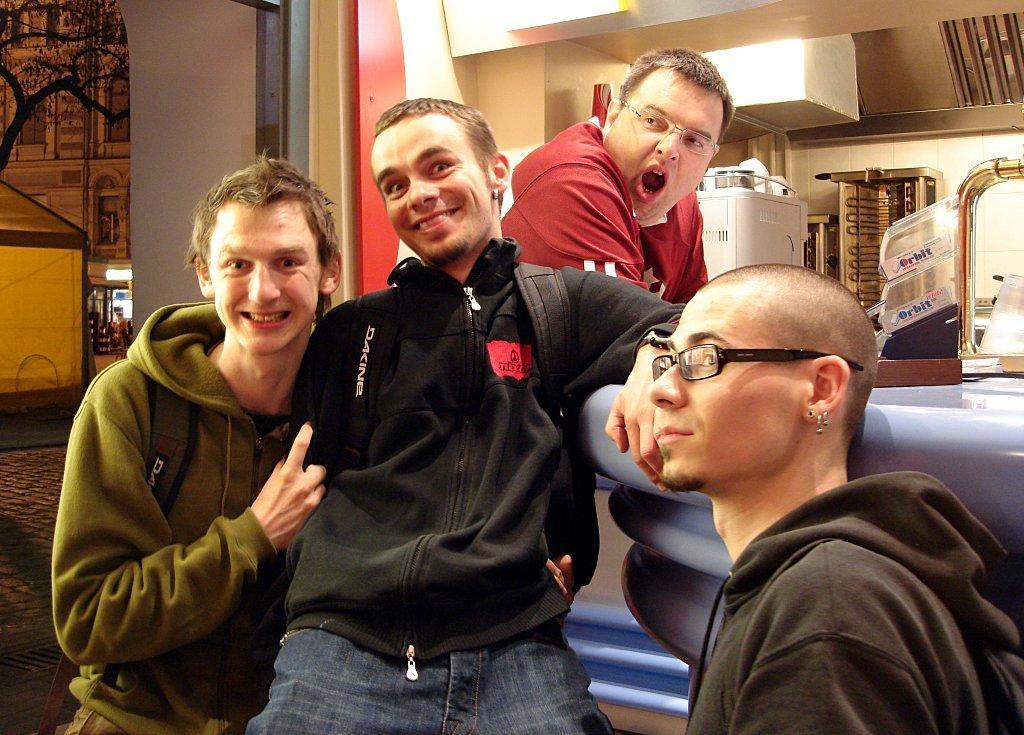Can you describe this image briefly? In the image we can see there are three men wearing clothes and two of them are wearing goggles and earrings. This is a footpath, tree, light and other objects. 